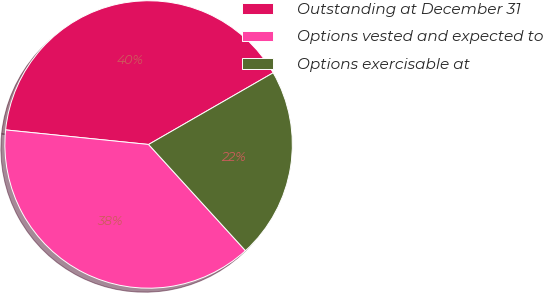<chart> <loc_0><loc_0><loc_500><loc_500><pie_chart><fcel>Outstanding at December 31<fcel>Options vested and expected to<fcel>Options exercisable at<nl><fcel>40.07%<fcel>38.38%<fcel>21.54%<nl></chart> 